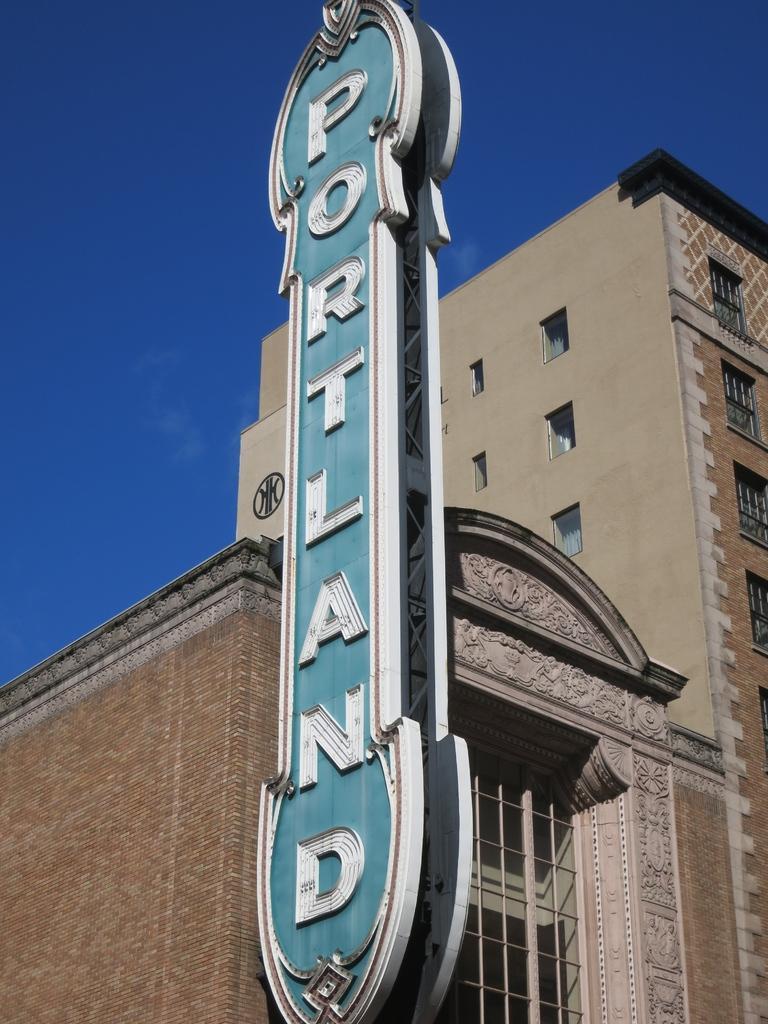In one or two sentences, can you explain what this image depicts? There is a building with windows. On the building there is a name board. In the background there is sky. 